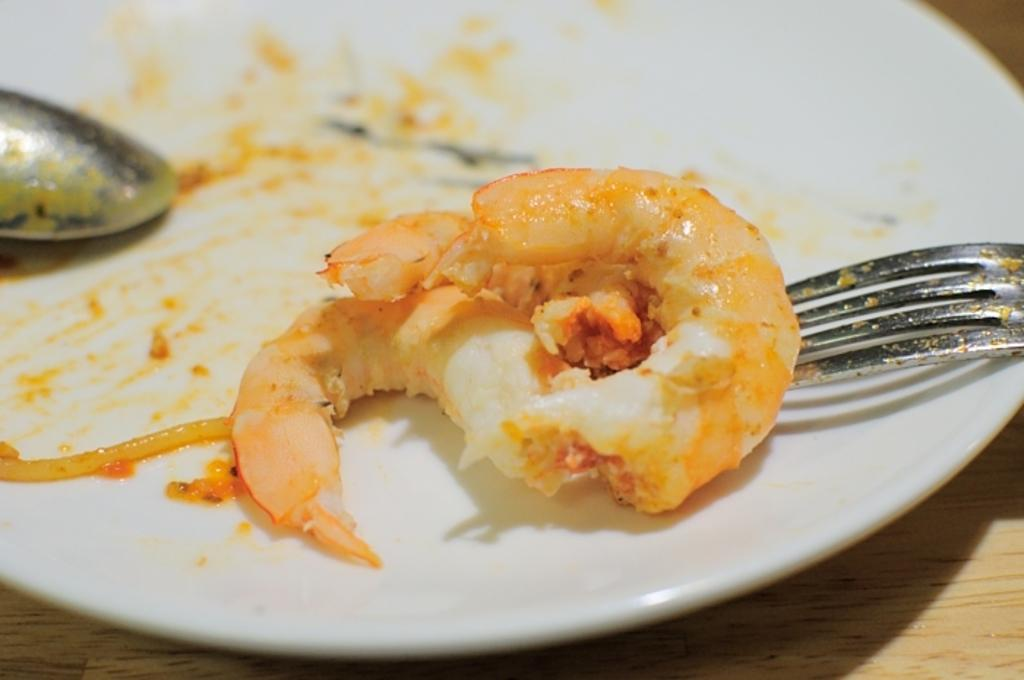What type of food can be seen in the image? The image contains food, but the specific type is not mentioned in the facts. What utensils are present on the plate in the image? There is a spoon and fork on a white plate in the image. What material is the object at the bottom of the image made of? The wooden object at the bottom of the image is made of wood. What type of wine is being served in the image? There is no wine present in the image. How many fingers are visible in the image? There is no mention of fingers in the image, as it only contains food, utensils, and a wooden object. 